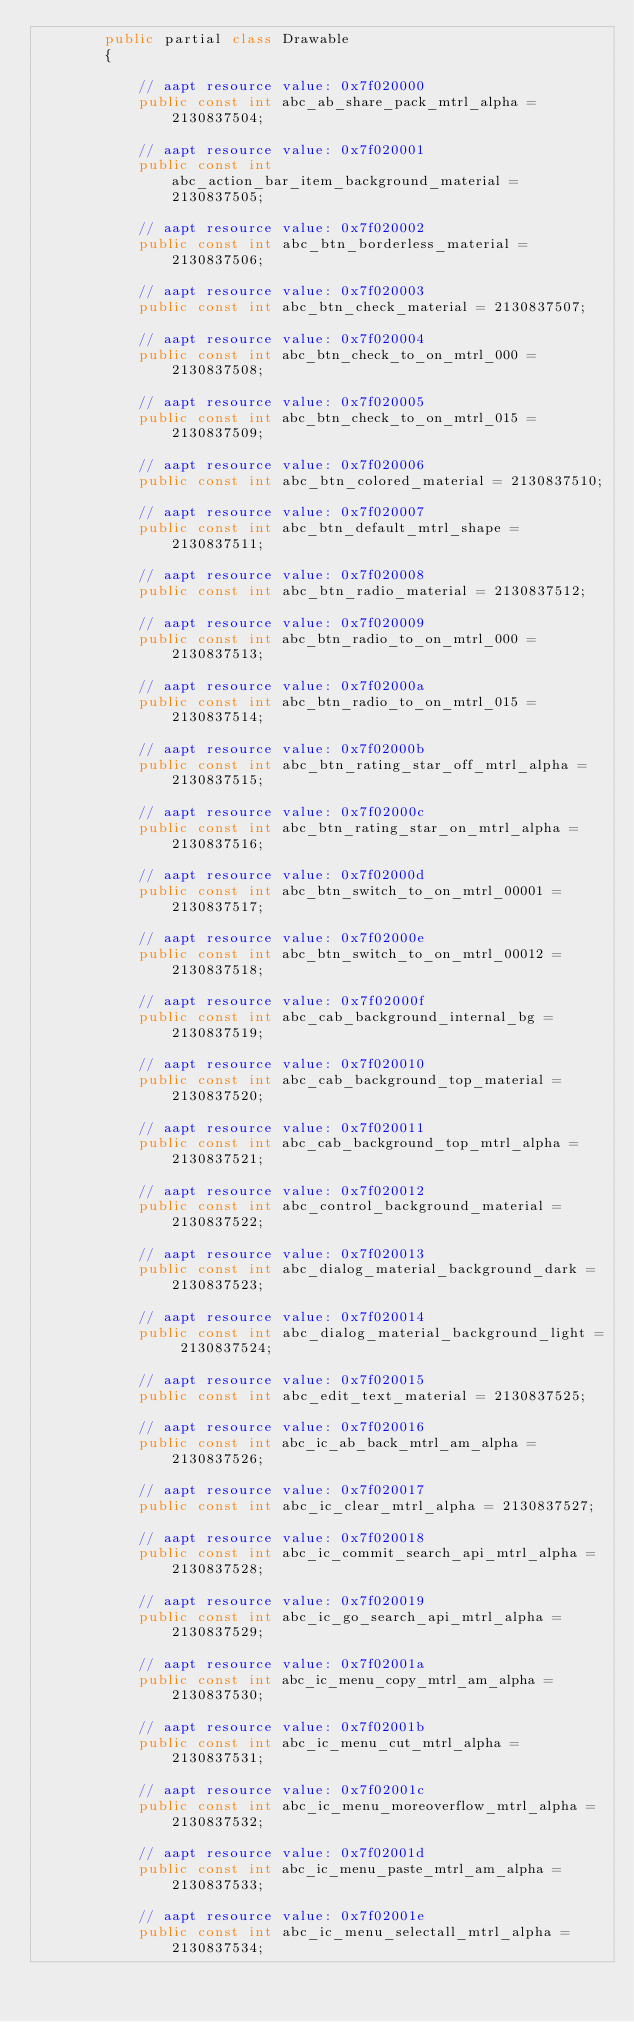Convert code to text. <code><loc_0><loc_0><loc_500><loc_500><_C#_>		public partial class Drawable
		{
			
			// aapt resource value: 0x7f020000
			public const int abc_ab_share_pack_mtrl_alpha = 2130837504;
			
			// aapt resource value: 0x7f020001
			public const int abc_action_bar_item_background_material = 2130837505;
			
			// aapt resource value: 0x7f020002
			public const int abc_btn_borderless_material = 2130837506;
			
			// aapt resource value: 0x7f020003
			public const int abc_btn_check_material = 2130837507;
			
			// aapt resource value: 0x7f020004
			public const int abc_btn_check_to_on_mtrl_000 = 2130837508;
			
			// aapt resource value: 0x7f020005
			public const int abc_btn_check_to_on_mtrl_015 = 2130837509;
			
			// aapt resource value: 0x7f020006
			public const int abc_btn_colored_material = 2130837510;
			
			// aapt resource value: 0x7f020007
			public const int abc_btn_default_mtrl_shape = 2130837511;
			
			// aapt resource value: 0x7f020008
			public const int abc_btn_radio_material = 2130837512;
			
			// aapt resource value: 0x7f020009
			public const int abc_btn_radio_to_on_mtrl_000 = 2130837513;
			
			// aapt resource value: 0x7f02000a
			public const int abc_btn_radio_to_on_mtrl_015 = 2130837514;
			
			// aapt resource value: 0x7f02000b
			public const int abc_btn_rating_star_off_mtrl_alpha = 2130837515;
			
			// aapt resource value: 0x7f02000c
			public const int abc_btn_rating_star_on_mtrl_alpha = 2130837516;
			
			// aapt resource value: 0x7f02000d
			public const int abc_btn_switch_to_on_mtrl_00001 = 2130837517;
			
			// aapt resource value: 0x7f02000e
			public const int abc_btn_switch_to_on_mtrl_00012 = 2130837518;
			
			// aapt resource value: 0x7f02000f
			public const int abc_cab_background_internal_bg = 2130837519;
			
			// aapt resource value: 0x7f020010
			public const int abc_cab_background_top_material = 2130837520;
			
			// aapt resource value: 0x7f020011
			public const int abc_cab_background_top_mtrl_alpha = 2130837521;
			
			// aapt resource value: 0x7f020012
			public const int abc_control_background_material = 2130837522;
			
			// aapt resource value: 0x7f020013
			public const int abc_dialog_material_background_dark = 2130837523;
			
			// aapt resource value: 0x7f020014
			public const int abc_dialog_material_background_light = 2130837524;
			
			// aapt resource value: 0x7f020015
			public const int abc_edit_text_material = 2130837525;
			
			// aapt resource value: 0x7f020016
			public const int abc_ic_ab_back_mtrl_am_alpha = 2130837526;
			
			// aapt resource value: 0x7f020017
			public const int abc_ic_clear_mtrl_alpha = 2130837527;
			
			// aapt resource value: 0x7f020018
			public const int abc_ic_commit_search_api_mtrl_alpha = 2130837528;
			
			// aapt resource value: 0x7f020019
			public const int abc_ic_go_search_api_mtrl_alpha = 2130837529;
			
			// aapt resource value: 0x7f02001a
			public const int abc_ic_menu_copy_mtrl_am_alpha = 2130837530;
			
			// aapt resource value: 0x7f02001b
			public const int abc_ic_menu_cut_mtrl_alpha = 2130837531;
			
			// aapt resource value: 0x7f02001c
			public const int abc_ic_menu_moreoverflow_mtrl_alpha = 2130837532;
			
			// aapt resource value: 0x7f02001d
			public const int abc_ic_menu_paste_mtrl_am_alpha = 2130837533;
			
			// aapt resource value: 0x7f02001e
			public const int abc_ic_menu_selectall_mtrl_alpha = 2130837534;
			</code> 